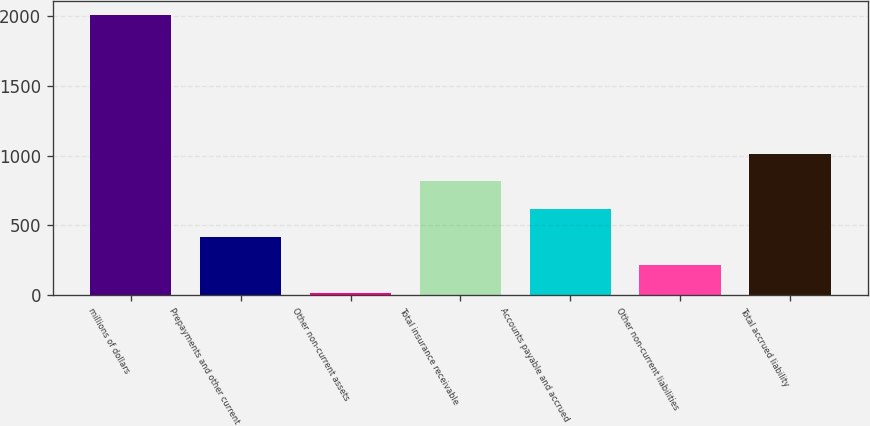Convert chart to OTSL. <chart><loc_0><loc_0><loc_500><loc_500><bar_chart><fcel>millions of dollars<fcel>Prepayments and other current<fcel>Other non-current assets<fcel>Total insurance receivable<fcel>Accounts payable and accrued<fcel>Other non-current liabilities<fcel>Total accrued liability<nl><fcel>2007<fcel>417<fcel>19.5<fcel>814.5<fcel>615.75<fcel>218.25<fcel>1013.25<nl></chart> 